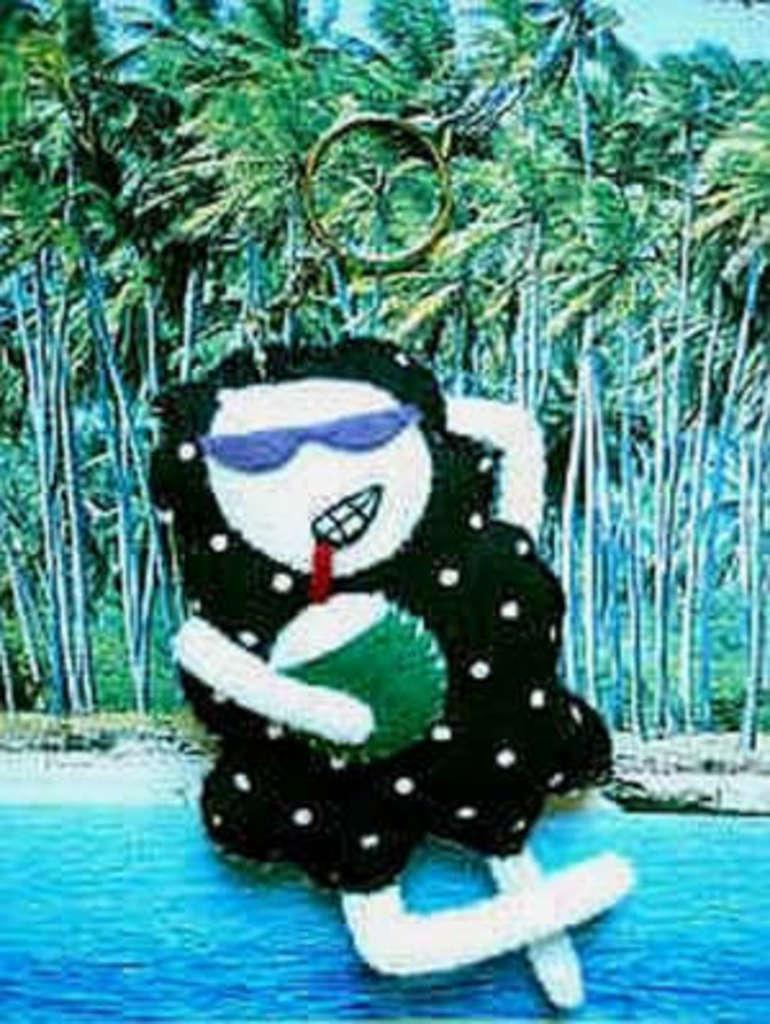What object is the main subject of the image? There is a keychain in the image. What can be seen in the background of the image? There are trees and a river in the background of the image. Is there a hospital visible in the image? There is no mention of a hospital in the image, and it is not visible in the provided facts. 